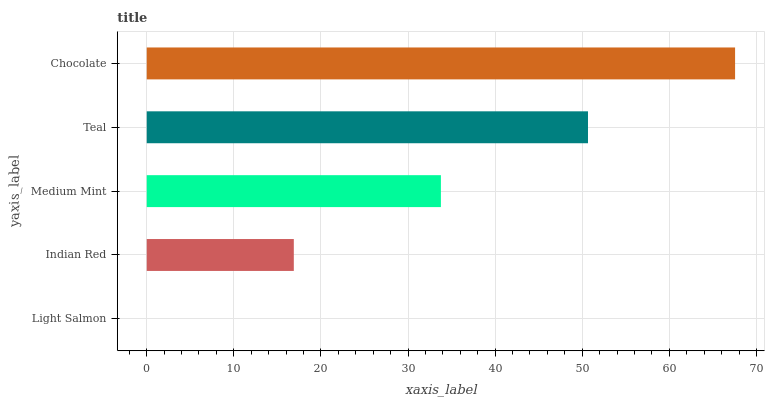Is Light Salmon the minimum?
Answer yes or no. Yes. Is Chocolate the maximum?
Answer yes or no. Yes. Is Indian Red the minimum?
Answer yes or no. No. Is Indian Red the maximum?
Answer yes or no. No. Is Indian Red greater than Light Salmon?
Answer yes or no. Yes. Is Light Salmon less than Indian Red?
Answer yes or no. Yes. Is Light Salmon greater than Indian Red?
Answer yes or no. No. Is Indian Red less than Light Salmon?
Answer yes or no. No. Is Medium Mint the high median?
Answer yes or no. Yes. Is Medium Mint the low median?
Answer yes or no. Yes. Is Chocolate the high median?
Answer yes or no. No. Is Chocolate the low median?
Answer yes or no. No. 